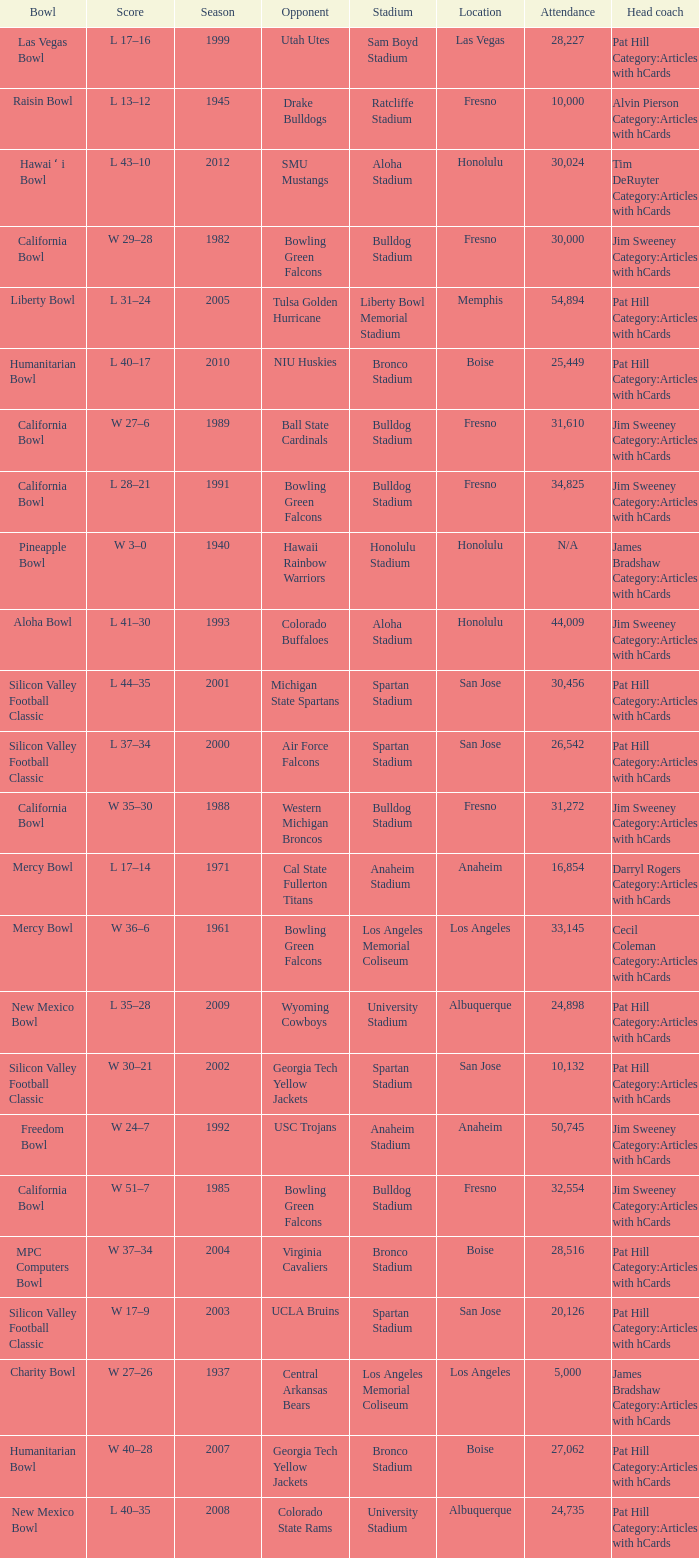Where was the California bowl played with 30,000 attending? Fresno. 